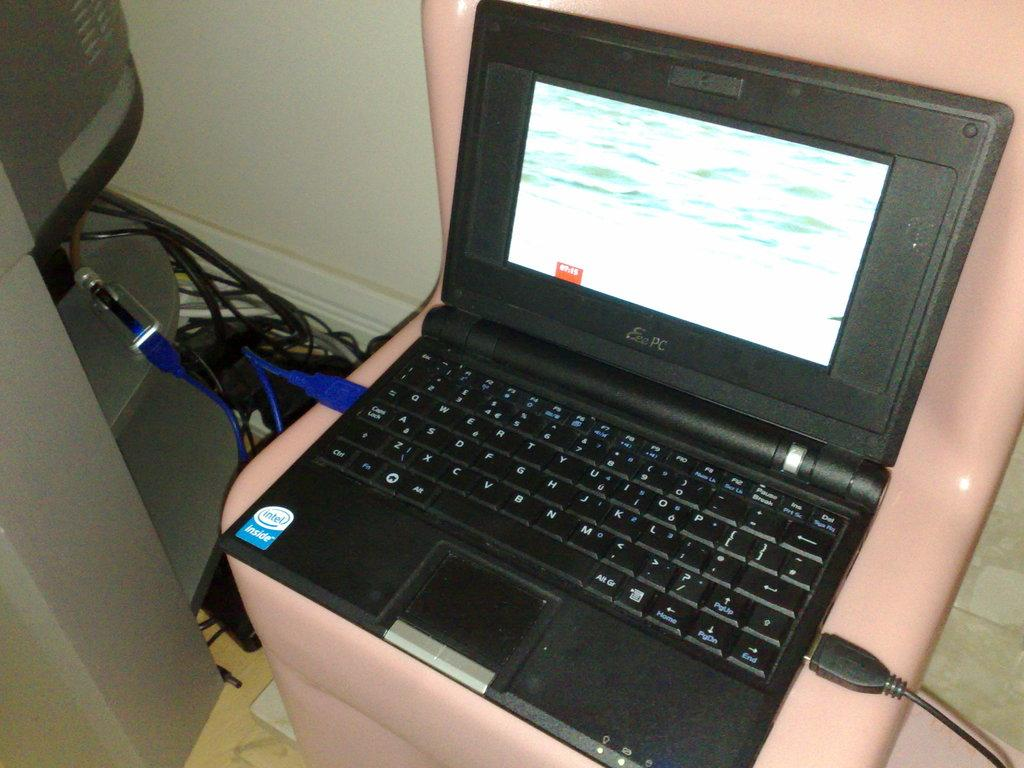<image>
Render a clear and concise summary of the photo. A small Eee laptop sitting on a pink chair with USB cable connected. 